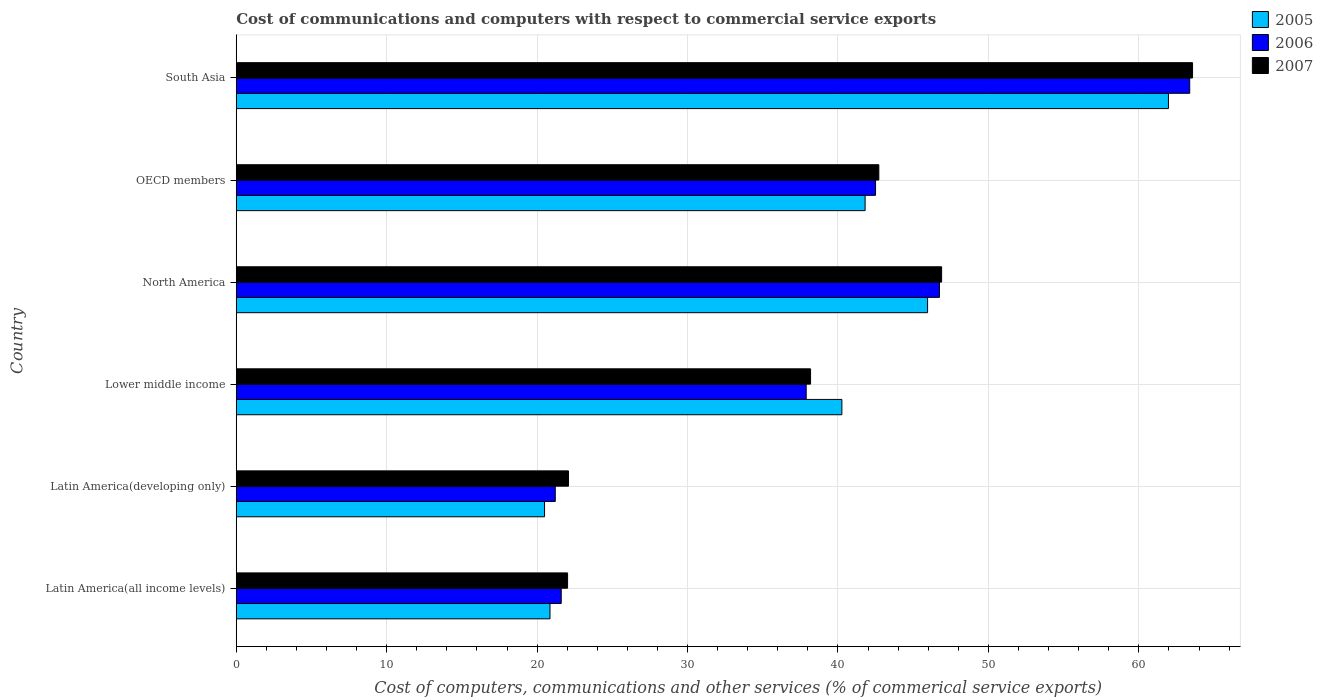How many groups of bars are there?
Offer a very short reply. 6. Are the number of bars on each tick of the Y-axis equal?
Ensure brevity in your answer.  Yes. How many bars are there on the 4th tick from the bottom?
Your answer should be compact. 3. What is the label of the 4th group of bars from the top?
Keep it short and to the point. Lower middle income. What is the cost of communications and computers in 2005 in OECD members?
Your answer should be very brief. 41.8. Across all countries, what is the maximum cost of communications and computers in 2005?
Make the answer very short. 61.97. Across all countries, what is the minimum cost of communications and computers in 2007?
Give a very brief answer. 22.02. In which country was the cost of communications and computers in 2006 maximum?
Keep it short and to the point. South Asia. In which country was the cost of communications and computers in 2006 minimum?
Your answer should be compact. Latin America(developing only). What is the total cost of communications and computers in 2007 in the graph?
Your response must be concise. 235.46. What is the difference between the cost of communications and computers in 2007 in Latin America(all income levels) and that in Lower middle income?
Give a very brief answer. -16.15. What is the difference between the cost of communications and computers in 2007 in Lower middle income and the cost of communications and computers in 2005 in North America?
Keep it short and to the point. -7.78. What is the average cost of communications and computers in 2006 per country?
Your response must be concise. 38.89. What is the difference between the cost of communications and computers in 2007 and cost of communications and computers in 2006 in North America?
Provide a succinct answer. 0.14. In how many countries, is the cost of communications and computers in 2007 greater than 56 %?
Give a very brief answer. 1. What is the ratio of the cost of communications and computers in 2007 in Latin America(developing only) to that in North America?
Give a very brief answer. 0.47. Is the difference between the cost of communications and computers in 2007 in Latin America(developing only) and North America greater than the difference between the cost of communications and computers in 2006 in Latin America(developing only) and North America?
Keep it short and to the point. Yes. What is the difference between the highest and the second highest cost of communications and computers in 2006?
Your response must be concise. 16.63. What is the difference between the highest and the lowest cost of communications and computers in 2007?
Your response must be concise. 41.55. In how many countries, is the cost of communications and computers in 2007 greater than the average cost of communications and computers in 2007 taken over all countries?
Provide a short and direct response. 3. Is the sum of the cost of communications and computers in 2006 in Latin America(all income levels) and North America greater than the maximum cost of communications and computers in 2005 across all countries?
Offer a very short reply. Yes. What does the 2nd bar from the bottom in Latin America(developing only) represents?
Keep it short and to the point. 2006. How many bars are there?
Your answer should be compact. 18. Are all the bars in the graph horizontal?
Provide a short and direct response. Yes. What is the difference between two consecutive major ticks on the X-axis?
Offer a very short reply. 10. Does the graph contain any zero values?
Ensure brevity in your answer.  No. Does the graph contain grids?
Provide a succinct answer. Yes. How many legend labels are there?
Offer a terse response. 3. How are the legend labels stacked?
Ensure brevity in your answer.  Vertical. What is the title of the graph?
Ensure brevity in your answer.  Cost of communications and computers with respect to commercial service exports. Does "1980" appear as one of the legend labels in the graph?
Make the answer very short. No. What is the label or title of the X-axis?
Your answer should be compact. Cost of computers, communications and other services (% of commerical service exports). What is the Cost of computers, communications and other services (% of commerical service exports) of 2005 in Latin America(all income levels)?
Your response must be concise. 20.86. What is the Cost of computers, communications and other services (% of commerical service exports) in 2006 in Latin America(all income levels)?
Give a very brief answer. 21.6. What is the Cost of computers, communications and other services (% of commerical service exports) of 2007 in Latin America(all income levels)?
Your answer should be compact. 22.02. What is the Cost of computers, communications and other services (% of commerical service exports) in 2005 in Latin America(developing only)?
Provide a short and direct response. 20.49. What is the Cost of computers, communications and other services (% of commerical service exports) in 2006 in Latin America(developing only)?
Your answer should be very brief. 21.21. What is the Cost of computers, communications and other services (% of commerical service exports) of 2007 in Latin America(developing only)?
Give a very brief answer. 22.09. What is the Cost of computers, communications and other services (% of commerical service exports) of 2005 in Lower middle income?
Your answer should be compact. 40.26. What is the Cost of computers, communications and other services (% of commerical service exports) of 2006 in Lower middle income?
Your response must be concise. 37.89. What is the Cost of computers, communications and other services (% of commerical service exports) in 2007 in Lower middle income?
Make the answer very short. 38.18. What is the Cost of computers, communications and other services (% of commerical service exports) in 2005 in North America?
Offer a very short reply. 45.96. What is the Cost of computers, communications and other services (% of commerical service exports) in 2006 in North America?
Provide a succinct answer. 46.75. What is the Cost of computers, communications and other services (% of commerical service exports) of 2007 in North America?
Your response must be concise. 46.89. What is the Cost of computers, communications and other services (% of commerical service exports) in 2005 in OECD members?
Give a very brief answer. 41.8. What is the Cost of computers, communications and other services (% of commerical service exports) of 2006 in OECD members?
Provide a succinct answer. 42.5. What is the Cost of computers, communications and other services (% of commerical service exports) in 2007 in OECD members?
Offer a terse response. 42.72. What is the Cost of computers, communications and other services (% of commerical service exports) in 2005 in South Asia?
Give a very brief answer. 61.97. What is the Cost of computers, communications and other services (% of commerical service exports) of 2006 in South Asia?
Your response must be concise. 63.38. What is the Cost of computers, communications and other services (% of commerical service exports) in 2007 in South Asia?
Your response must be concise. 63.57. Across all countries, what is the maximum Cost of computers, communications and other services (% of commerical service exports) in 2005?
Your answer should be very brief. 61.97. Across all countries, what is the maximum Cost of computers, communications and other services (% of commerical service exports) in 2006?
Ensure brevity in your answer.  63.38. Across all countries, what is the maximum Cost of computers, communications and other services (% of commerical service exports) in 2007?
Provide a short and direct response. 63.57. Across all countries, what is the minimum Cost of computers, communications and other services (% of commerical service exports) of 2005?
Give a very brief answer. 20.49. Across all countries, what is the minimum Cost of computers, communications and other services (% of commerical service exports) in 2006?
Provide a succinct answer. 21.21. Across all countries, what is the minimum Cost of computers, communications and other services (% of commerical service exports) in 2007?
Offer a very short reply. 22.02. What is the total Cost of computers, communications and other services (% of commerical service exports) of 2005 in the graph?
Your answer should be compact. 231.34. What is the total Cost of computers, communications and other services (% of commerical service exports) in 2006 in the graph?
Provide a succinct answer. 233.32. What is the total Cost of computers, communications and other services (% of commerical service exports) in 2007 in the graph?
Offer a terse response. 235.46. What is the difference between the Cost of computers, communications and other services (% of commerical service exports) of 2005 in Latin America(all income levels) and that in Latin America(developing only)?
Give a very brief answer. 0.36. What is the difference between the Cost of computers, communications and other services (% of commerical service exports) in 2006 in Latin America(all income levels) and that in Latin America(developing only)?
Your answer should be very brief. 0.4. What is the difference between the Cost of computers, communications and other services (% of commerical service exports) of 2007 in Latin America(all income levels) and that in Latin America(developing only)?
Offer a terse response. -0.06. What is the difference between the Cost of computers, communications and other services (% of commerical service exports) in 2005 in Latin America(all income levels) and that in Lower middle income?
Make the answer very short. -19.4. What is the difference between the Cost of computers, communications and other services (% of commerical service exports) of 2006 in Latin America(all income levels) and that in Lower middle income?
Provide a succinct answer. -16.28. What is the difference between the Cost of computers, communications and other services (% of commerical service exports) in 2007 in Latin America(all income levels) and that in Lower middle income?
Provide a succinct answer. -16.15. What is the difference between the Cost of computers, communications and other services (% of commerical service exports) in 2005 in Latin America(all income levels) and that in North America?
Provide a short and direct response. -25.1. What is the difference between the Cost of computers, communications and other services (% of commerical service exports) in 2006 in Latin America(all income levels) and that in North America?
Provide a short and direct response. -25.14. What is the difference between the Cost of computers, communications and other services (% of commerical service exports) of 2007 in Latin America(all income levels) and that in North America?
Offer a terse response. -24.87. What is the difference between the Cost of computers, communications and other services (% of commerical service exports) of 2005 in Latin America(all income levels) and that in OECD members?
Your response must be concise. -20.95. What is the difference between the Cost of computers, communications and other services (% of commerical service exports) in 2006 in Latin America(all income levels) and that in OECD members?
Keep it short and to the point. -20.89. What is the difference between the Cost of computers, communications and other services (% of commerical service exports) in 2007 in Latin America(all income levels) and that in OECD members?
Provide a succinct answer. -20.69. What is the difference between the Cost of computers, communications and other services (% of commerical service exports) in 2005 in Latin America(all income levels) and that in South Asia?
Offer a very short reply. -41.11. What is the difference between the Cost of computers, communications and other services (% of commerical service exports) of 2006 in Latin America(all income levels) and that in South Asia?
Offer a very short reply. -41.78. What is the difference between the Cost of computers, communications and other services (% of commerical service exports) in 2007 in Latin America(all income levels) and that in South Asia?
Your response must be concise. -41.55. What is the difference between the Cost of computers, communications and other services (% of commerical service exports) of 2005 in Latin America(developing only) and that in Lower middle income?
Provide a short and direct response. -19.76. What is the difference between the Cost of computers, communications and other services (% of commerical service exports) in 2006 in Latin America(developing only) and that in Lower middle income?
Offer a very short reply. -16.68. What is the difference between the Cost of computers, communications and other services (% of commerical service exports) of 2007 in Latin America(developing only) and that in Lower middle income?
Offer a very short reply. -16.09. What is the difference between the Cost of computers, communications and other services (% of commerical service exports) of 2005 in Latin America(developing only) and that in North America?
Your answer should be very brief. -25.46. What is the difference between the Cost of computers, communications and other services (% of commerical service exports) in 2006 in Latin America(developing only) and that in North America?
Provide a short and direct response. -25.54. What is the difference between the Cost of computers, communications and other services (% of commerical service exports) in 2007 in Latin America(developing only) and that in North America?
Keep it short and to the point. -24.8. What is the difference between the Cost of computers, communications and other services (% of commerical service exports) of 2005 in Latin America(developing only) and that in OECD members?
Offer a terse response. -21.31. What is the difference between the Cost of computers, communications and other services (% of commerical service exports) of 2006 in Latin America(developing only) and that in OECD members?
Provide a short and direct response. -21.29. What is the difference between the Cost of computers, communications and other services (% of commerical service exports) in 2007 in Latin America(developing only) and that in OECD members?
Your response must be concise. -20.63. What is the difference between the Cost of computers, communications and other services (% of commerical service exports) of 2005 in Latin America(developing only) and that in South Asia?
Your answer should be very brief. -41.47. What is the difference between the Cost of computers, communications and other services (% of commerical service exports) in 2006 in Latin America(developing only) and that in South Asia?
Your answer should be very brief. -42.17. What is the difference between the Cost of computers, communications and other services (% of commerical service exports) of 2007 in Latin America(developing only) and that in South Asia?
Give a very brief answer. -41.48. What is the difference between the Cost of computers, communications and other services (% of commerical service exports) in 2005 in Lower middle income and that in North America?
Keep it short and to the point. -5.7. What is the difference between the Cost of computers, communications and other services (% of commerical service exports) in 2006 in Lower middle income and that in North America?
Make the answer very short. -8.86. What is the difference between the Cost of computers, communications and other services (% of commerical service exports) in 2007 in Lower middle income and that in North America?
Your response must be concise. -8.71. What is the difference between the Cost of computers, communications and other services (% of commerical service exports) of 2005 in Lower middle income and that in OECD members?
Give a very brief answer. -1.54. What is the difference between the Cost of computers, communications and other services (% of commerical service exports) in 2006 in Lower middle income and that in OECD members?
Your response must be concise. -4.61. What is the difference between the Cost of computers, communications and other services (% of commerical service exports) of 2007 in Lower middle income and that in OECD members?
Provide a succinct answer. -4.54. What is the difference between the Cost of computers, communications and other services (% of commerical service exports) in 2005 in Lower middle income and that in South Asia?
Give a very brief answer. -21.71. What is the difference between the Cost of computers, communications and other services (% of commerical service exports) in 2006 in Lower middle income and that in South Asia?
Keep it short and to the point. -25.5. What is the difference between the Cost of computers, communications and other services (% of commerical service exports) in 2007 in Lower middle income and that in South Asia?
Give a very brief answer. -25.39. What is the difference between the Cost of computers, communications and other services (% of commerical service exports) in 2005 in North America and that in OECD members?
Your response must be concise. 4.15. What is the difference between the Cost of computers, communications and other services (% of commerical service exports) in 2006 in North America and that in OECD members?
Keep it short and to the point. 4.25. What is the difference between the Cost of computers, communications and other services (% of commerical service exports) in 2007 in North America and that in OECD members?
Your response must be concise. 4.17. What is the difference between the Cost of computers, communications and other services (% of commerical service exports) in 2005 in North America and that in South Asia?
Keep it short and to the point. -16.01. What is the difference between the Cost of computers, communications and other services (% of commerical service exports) of 2006 in North America and that in South Asia?
Give a very brief answer. -16.63. What is the difference between the Cost of computers, communications and other services (% of commerical service exports) in 2007 in North America and that in South Asia?
Ensure brevity in your answer.  -16.68. What is the difference between the Cost of computers, communications and other services (% of commerical service exports) of 2005 in OECD members and that in South Asia?
Keep it short and to the point. -20.16. What is the difference between the Cost of computers, communications and other services (% of commerical service exports) in 2006 in OECD members and that in South Asia?
Give a very brief answer. -20.88. What is the difference between the Cost of computers, communications and other services (% of commerical service exports) in 2007 in OECD members and that in South Asia?
Offer a terse response. -20.85. What is the difference between the Cost of computers, communications and other services (% of commerical service exports) in 2005 in Latin America(all income levels) and the Cost of computers, communications and other services (% of commerical service exports) in 2006 in Latin America(developing only)?
Offer a very short reply. -0.35. What is the difference between the Cost of computers, communications and other services (% of commerical service exports) of 2005 in Latin America(all income levels) and the Cost of computers, communications and other services (% of commerical service exports) of 2007 in Latin America(developing only)?
Offer a very short reply. -1.23. What is the difference between the Cost of computers, communications and other services (% of commerical service exports) of 2006 in Latin America(all income levels) and the Cost of computers, communications and other services (% of commerical service exports) of 2007 in Latin America(developing only)?
Provide a short and direct response. -0.48. What is the difference between the Cost of computers, communications and other services (% of commerical service exports) in 2005 in Latin America(all income levels) and the Cost of computers, communications and other services (% of commerical service exports) in 2006 in Lower middle income?
Your answer should be compact. -17.03. What is the difference between the Cost of computers, communications and other services (% of commerical service exports) of 2005 in Latin America(all income levels) and the Cost of computers, communications and other services (% of commerical service exports) of 2007 in Lower middle income?
Offer a very short reply. -17.32. What is the difference between the Cost of computers, communications and other services (% of commerical service exports) in 2006 in Latin America(all income levels) and the Cost of computers, communications and other services (% of commerical service exports) in 2007 in Lower middle income?
Your answer should be very brief. -16.57. What is the difference between the Cost of computers, communications and other services (% of commerical service exports) in 2005 in Latin America(all income levels) and the Cost of computers, communications and other services (% of commerical service exports) in 2006 in North America?
Keep it short and to the point. -25.89. What is the difference between the Cost of computers, communications and other services (% of commerical service exports) in 2005 in Latin America(all income levels) and the Cost of computers, communications and other services (% of commerical service exports) in 2007 in North America?
Your response must be concise. -26.03. What is the difference between the Cost of computers, communications and other services (% of commerical service exports) of 2006 in Latin America(all income levels) and the Cost of computers, communications and other services (% of commerical service exports) of 2007 in North America?
Your answer should be compact. -25.29. What is the difference between the Cost of computers, communications and other services (% of commerical service exports) of 2005 in Latin America(all income levels) and the Cost of computers, communications and other services (% of commerical service exports) of 2006 in OECD members?
Your response must be concise. -21.64. What is the difference between the Cost of computers, communications and other services (% of commerical service exports) of 2005 in Latin America(all income levels) and the Cost of computers, communications and other services (% of commerical service exports) of 2007 in OECD members?
Make the answer very short. -21.86. What is the difference between the Cost of computers, communications and other services (% of commerical service exports) of 2006 in Latin America(all income levels) and the Cost of computers, communications and other services (% of commerical service exports) of 2007 in OECD members?
Offer a very short reply. -21.11. What is the difference between the Cost of computers, communications and other services (% of commerical service exports) in 2005 in Latin America(all income levels) and the Cost of computers, communications and other services (% of commerical service exports) in 2006 in South Asia?
Provide a succinct answer. -42.52. What is the difference between the Cost of computers, communications and other services (% of commerical service exports) of 2005 in Latin America(all income levels) and the Cost of computers, communications and other services (% of commerical service exports) of 2007 in South Asia?
Offer a terse response. -42.71. What is the difference between the Cost of computers, communications and other services (% of commerical service exports) of 2006 in Latin America(all income levels) and the Cost of computers, communications and other services (% of commerical service exports) of 2007 in South Asia?
Make the answer very short. -41.97. What is the difference between the Cost of computers, communications and other services (% of commerical service exports) in 2005 in Latin America(developing only) and the Cost of computers, communications and other services (% of commerical service exports) in 2006 in Lower middle income?
Your answer should be compact. -17.39. What is the difference between the Cost of computers, communications and other services (% of commerical service exports) in 2005 in Latin America(developing only) and the Cost of computers, communications and other services (% of commerical service exports) in 2007 in Lower middle income?
Your response must be concise. -17.68. What is the difference between the Cost of computers, communications and other services (% of commerical service exports) of 2006 in Latin America(developing only) and the Cost of computers, communications and other services (% of commerical service exports) of 2007 in Lower middle income?
Your answer should be compact. -16.97. What is the difference between the Cost of computers, communications and other services (% of commerical service exports) of 2005 in Latin America(developing only) and the Cost of computers, communications and other services (% of commerical service exports) of 2006 in North America?
Give a very brief answer. -26.25. What is the difference between the Cost of computers, communications and other services (% of commerical service exports) in 2005 in Latin America(developing only) and the Cost of computers, communications and other services (% of commerical service exports) in 2007 in North America?
Your response must be concise. -26.4. What is the difference between the Cost of computers, communications and other services (% of commerical service exports) in 2006 in Latin America(developing only) and the Cost of computers, communications and other services (% of commerical service exports) in 2007 in North America?
Keep it short and to the point. -25.68. What is the difference between the Cost of computers, communications and other services (% of commerical service exports) of 2005 in Latin America(developing only) and the Cost of computers, communications and other services (% of commerical service exports) of 2006 in OECD members?
Your answer should be very brief. -22. What is the difference between the Cost of computers, communications and other services (% of commerical service exports) in 2005 in Latin America(developing only) and the Cost of computers, communications and other services (% of commerical service exports) in 2007 in OECD members?
Your response must be concise. -22.22. What is the difference between the Cost of computers, communications and other services (% of commerical service exports) in 2006 in Latin America(developing only) and the Cost of computers, communications and other services (% of commerical service exports) in 2007 in OECD members?
Offer a very short reply. -21.51. What is the difference between the Cost of computers, communications and other services (% of commerical service exports) of 2005 in Latin America(developing only) and the Cost of computers, communications and other services (% of commerical service exports) of 2006 in South Asia?
Your answer should be very brief. -42.89. What is the difference between the Cost of computers, communications and other services (% of commerical service exports) of 2005 in Latin America(developing only) and the Cost of computers, communications and other services (% of commerical service exports) of 2007 in South Asia?
Offer a very short reply. -43.08. What is the difference between the Cost of computers, communications and other services (% of commerical service exports) in 2006 in Latin America(developing only) and the Cost of computers, communications and other services (% of commerical service exports) in 2007 in South Asia?
Ensure brevity in your answer.  -42.36. What is the difference between the Cost of computers, communications and other services (% of commerical service exports) of 2005 in Lower middle income and the Cost of computers, communications and other services (% of commerical service exports) of 2006 in North America?
Provide a short and direct response. -6.49. What is the difference between the Cost of computers, communications and other services (% of commerical service exports) in 2005 in Lower middle income and the Cost of computers, communications and other services (% of commerical service exports) in 2007 in North America?
Your response must be concise. -6.63. What is the difference between the Cost of computers, communications and other services (% of commerical service exports) of 2006 in Lower middle income and the Cost of computers, communications and other services (% of commerical service exports) of 2007 in North America?
Keep it short and to the point. -9. What is the difference between the Cost of computers, communications and other services (% of commerical service exports) in 2005 in Lower middle income and the Cost of computers, communications and other services (% of commerical service exports) in 2006 in OECD members?
Keep it short and to the point. -2.24. What is the difference between the Cost of computers, communications and other services (% of commerical service exports) in 2005 in Lower middle income and the Cost of computers, communications and other services (% of commerical service exports) in 2007 in OECD members?
Provide a succinct answer. -2.46. What is the difference between the Cost of computers, communications and other services (% of commerical service exports) of 2006 in Lower middle income and the Cost of computers, communications and other services (% of commerical service exports) of 2007 in OECD members?
Offer a very short reply. -4.83. What is the difference between the Cost of computers, communications and other services (% of commerical service exports) of 2005 in Lower middle income and the Cost of computers, communications and other services (% of commerical service exports) of 2006 in South Asia?
Ensure brevity in your answer.  -23.12. What is the difference between the Cost of computers, communications and other services (% of commerical service exports) of 2005 in Lower middle income and the Cost of computers, communications and other services (% of commerical service exports) of 2007 in South Asia?
Keep it short and to the point. -23.31. What is the difference between the Cost of computers, communications and other services (% of commerical service exports) of 2006 in Lower middle income and the Cost of computers, communications and other services (% of commerical service exports) of 2007 in South Asia?
Ensure brevity in your answer.  -25.68. What is the difference between the Cost of computers, communications and other services (% of commerical service exports) in 2005 in North America and the Cost of computers, communications and other services (% of commerical service exports) in 2006 in OECD members?
Provide a succinct answer. 3.46. What is the difference between the Cost of computers, communications and other services (% of commerical service exports) in 2005 in North America and the Cost of computers, communications and other services (% of commerical service exports) in 2007 in OECD members?
Give a very brief answer. 3.24. What is the difference between the Cost of computers, communications and other services (% of commerical service exports) of 2006 in North America and the Cost of computers, communications and other services (% of commerical service exports) of 2007 in OECD members?
Give a very brief answer. 4.03. What is the difference between the Cost of computers, communications and other services (% of commerical service exports) of 2005 in North America and the Cost of computers, communications and other services (% of commerical service exports) of 2006 in South Asia?
Keep it short and to the point. -17.43. What is the difference between the Cost of computers, communications and other services (% of commerical service exports) of 2005 in North America and the Cost of computers, communications and other services (% of commerical service exports) of 2007 in South Asia?
Offer a terse response. -17.61. What is the difference between the Cost of computers, communications and other services (% of commerical service exports) of 2006 in North America and the Cost of computers, communications and other services (% of commerical service exports) of 2007 in South Asia?
Provide a short and direct response. -16.82. What is the difference between the Cost of computers, communications and other services (% of commerical service exports) in 2005 in OECD members and the Cost of computers, communications and other services (% of commerical service exports) in 2006 in South Asia?
Give a very brief answer. -21.58. What is the difference between the Cost of computers, communications and other services (% of commerical service exports) of 2005 in OECD members and the Cost of computers, communications and other services (% of commerical service exports) of 2007 in South Asia?
Give a very brief answer. -21.77. What is the difference between the Cost of computers, communications and other services (% of commerical service exports) in 2006 in OECD members and the Cost of computers, communications and other services (% of commerical service exports) in 2007 in South Asia?
Provide a short and direct response. -21.07. What is the average Cost of computers, communications and other services (% of commerical service exports) in 2005 per country?
Make the answer very short. 38.56. What is the average Cost of computers, communications and other services (% of commerical service exports) in 2006 per country?
Your response must be concise. 38.89. What is the average Cost of computers, communications and other services (% of commerical service exports) of 2007 per country?
Make the answer very short. 39.24. What is the difference between the Cost of computers, communications and other services (% of commerical service exports) in 2005 and Cost of computers, communications and other services (% of commerical service exports) in 2006 in Latin America(all income levels)?
Your answer should be compact. -0.75. What is the difference between the Cost of computers, communications and other services (% of commerical service exports) in 2005 and Cost of computers, communications and other services (% of commerical service exports) in 2007 in Latin America(all income levels)?
Provide a short and direct response. -1.17. What is the difference between the Cost of computers, communications and other services (% of commerical service exports) in 2006 and Cost of computers, communications and other services (% of commerical service exports) in 2007 in Latin America(all income levels)?
Make the answer very short. -0.42. What is the difference between the Cost of computers, communications and other services (% of commerical service exports) in 2005 and Cost of computers, communications and other services (% of commerical service exports) in 2006 in Latin America(developing only)?
Keep it short and to the point. -0.71. What is the difference between the Cost of computers, communications and other services (% of commerical service exports) in 2005 and Cost of computers, communications and other services (% of commerical service exports) in 2007 in Latin America(developing only)?
Your response must be concise. -1.59. What is the difference between the Cost of computers, communications and other services (% of commerical service exports) in 2006 and Cost of computers, communications and other services (% of commerical service exports) in 2007 in Latin America(developing only)?
Make the answer very short. -0.88. What is the difference between the Cost of computers, communications and other services (% of commerical service exports) in 2005 and Cost of computers, communications and other services (% of commerical service exports) in 2006 in Lower middle income?
Provide a short and direct response. 2.37. What is the difference between the Cost of computers, communications and other services (% of commerical service exports) of 2005 and Cost of computers, communications and other services (% of commerical service exports) of 2007 in Lower middle income?
Your response must be concise. 2.08. What is the difference between the Cost of computers, communications and other services (% of commerical service exports) in 2006 and Cost of computers, communications and other services (% of commerical service exports) in 2007 in Lower middle income?
Make the answer very short. -0.29. What is the difference between the Cost of computers, communications and other services (% of commerical service exports) of 2005 and Cost of computers, communications and other services (% of commerical service exports) of 2006 in North America?
Your answer should be very brief. -0.79. What is the difference between the Cost of computers, communications and other services (% of commerical service exports) in 2005 and Cost of computers, communications and other services (% of commerical service exports) in 2007 in North America?
Make the answer very short. -0.93. What is the difference between the Cost of computers, communications and other services (% of commerical service exports) of 2006 and Cost of computers, communications and other services (% of commerical service exports) of 2007 in North America?
Keep it short and to the point. -0.14. What is the difference between the Cost of computers, communications and other services (% of commerical service exports) in 2005 and Cost of computers, communications and other services (% of commerical service exports) in 2006 in OECD members?
Your answer should be very brief. -0.69. What is the difference between the Cost of computers, communications and other services (% of commerical service exports) in 2005 and Cost of computers, communications and other services (% of commerical service exports) in 2007 in OECD members?
Offer a terse response. -0.91. What is the difference between the Cost of computers, communications and other services (% of commerical service exports) of 2006 and Cost of computers, communications and other services (% of commerical service exports) of 2007 in OECD members?
Your answer should be very brief. -0.22. What is the difference between the Cost of computers, communications and other services (% of commerical service exports) in 2005 and Cost of computers, communications and other services (% of commerical service exports) in 2006 in South Asia?
Your response must be concise. -1.41. What is the difference between the Cost of computers, communications and other services (% of commerical service exports) in 2005 and Cost of computers, communications and other services (% of commerical service exports) in 2007 in South Asia?
Your response must be concise. -1.6. What is the difference between the Cost of computers, communications and other services (% of commerical service exports) in 2006 and Cost of computers, communications and other services (% of commerical service exports) in 2007 in South Asia?
Provide a succinct answer. -0.19. What is the ratio of the Cost of computers, communications and other services (% of commerical service exports) in 2005 in Latin America(all income levels) to that in Latin America(developing only)?
Offer a very short reply. 1.02. What is the ratio of the Cost of computers, communications and other services (% of commerical service exports) of 2006 in Latin America(all income levels) to that in Latin America(developing only)?
Offer a very short reply. 1.02. What is the ratio of the Cost of computers, communications and other services (% of commerical service exports) in 2005 in Latin America(all income levels) to that in Lower middle income?
Give a very brief answer. 0.52. What is the ratio of the Cost of computers, communications and other services (% of commerical service exports) of 2006 in Latin America(all income levels) to that in Lower middle income?
Your response must be concise. 0.57. What is the ratio of the Cost of computers, communications and other services (% of commerical service exports) of 2007 in Latin America(all income levels) to that in Lower middle income?
Your response must be concise. 0.58. What is the ratio of the Cost of computers, communications and other services (% of commerical service exports) of 2005 in Latin America(all income levels) to that in North America?
Give a very brief answer. 0.45. What is the ratio of the Cost of computers, communications and other services (% of commerical service exports) in 2006 in Latin America(all income levels) to that in North America?
Make the answer very short. 0.46. What is the ratio of the Cost of computers, communications and other services (% of commerical service exports) in 2007 in Latin America(all income levels) to that in North America?
Give a very brief answer. 0.47. What is the ratio of the Cost of computers, communications and other services (% of commerical service exports) of 2005 in Latin America(all income levels) to that in OECD members?
Provide a succinct answer. 0.5. What is the ratio of the Cost of computers, communications and other services (% of commerical service exports) in 2006 in Latin America(all income levels) to that in OECD members?
Ensure brevity in your answer.  0.51. What is the ratio of the Cost of computers, communications and other services (% of commerical service exports) in 2007 in Latin America(all income levels) to that in OECD members?
Your answer should be compact. 0.52. What is the ratio of the Cost of computers, communications and other services (% of commerical service exports) of 2005 in Latin America(all income levels) to that in South Asia?
Offer a very short reply. 0.34. What is the ratio of the Cost of computers, communications and other services (% of commerical service exports) in 2006 in Latin America(all income levels) to that in South Asia?
Keep it short and to the point. 0.34. What is the ratio of the Cost of computers, communications and other services (% of commerical service exports) in 2007 in Latin America(all income levels) to that in South Asia?
Ensure brevity in your answer.  0.35. What is the ratio of the Cost of computers, communications and other services (% of commerical service exports) of 2005 in Latin America(developing only) to that in Lower middle income?
Your answer should be compact. 0.51. What is the ratio of the Cost of computers, communications and other services (% of commerical service exports) in 2006 in Latin America(developing only) to that in Lower middle income?
Provide a succinct answer. 0.56. What is the ratio of the Cost of computers, communications and other services (% of commerical service exports) in 2007 in Latin America(developing only) to that in Lower middle income?
Offer a terse response. 0.58. What is the ratio of the Cost of computers, communications and other services (% of commerical service exports) in 2005 in Latin America(developing only) to that in North America?
Ensure brevity in your answer.  0.45. What is the ratio of the Cost of computers, communications and other services (% of commerical service exports) in 2006 in Latin America(developing only) to that in North America?
Make the answer very short. 0.45. What is the ratio of the Cost of computers, communications and other services (% of commerical service exports) of 2007 in Latin America(developing only) to that in North America?
Give a very brief answer. 0.47. What is the ratio of the Cost of computers, communications and other services (% of commerical service exports) of 2005 in Latin America(developing only) to that in OECD members?
Your response must be concise. 0.49. What is the ratio of the Cost of computers, communications and other services (% of commerical service exports) in 2006 in Latin America(developing only) to that in OECD members?
Offer a terse response. 0.5. What is the ratio of the Cost of computers, communications and other services (% of commerical service exports) in 2007 in Latin America(developing only) to that in OECD members?
Your answer should be very brief. 0.52. What is the ratio of the Cost of computers, communications and other services (% of commerical service exports) of 2005 in Latin America(developing only) to that in South Asia?
Your answer should be very brief. 0.33. What is the ratio of the Cost of computers, communications and other services (% of commerical service exports) of 2006 in Latin America(developing only) to that in South Asia?
Offer a very short reply. 0.33. What is the ratio of the Cost of computers, communications and other services (% of commerical service exports) in 2007 in Latin America(developing only) to that in South Asia?
Offer a terse response. 0.35. What is the ratio of the Cost of computers, communications and other services (% of commerical service exports) in 2005 in Lower middle income to that in North America?
Make the answer very short. 0.88. What is the ratio of the Cost of computers, communications and other services (% of commerical service exports) of 2006 in Lower middle income to that in North America?
Offer a very short reply. 0.81. What is the ratio of the Cost of computers, communications and other services (% of commerical service exports) in 2007 in Lower middle income to that in North America?
Ensure brevity in your answer.  0.81. What is the ratio of the Cost of computers, communications and other services (% of commerical service exports) in 2005 in Lower middle income to that in OECD members?
Offer a terse response. 0.96. What is the ratio of the Cost of computers, communications and other services (% of commerical service exports) in 2006 in Lower middle income to that in OECD members?
Offer a terse response. 0.89. What is the ratio of the Cost of computers, communications and other services (% of commerical service exports) in 2007 in Lower middle income to that in OECD members?
Your answer should be very brief. 0.89. What is the ratio of the Cost of computers, communications and other services (% of commerical service exports) of 2005 in Lower middle income to that in South Asia?
Provide a short and direct response. 0.65. What is the ratio of the Cost of computers, communications and other services (% of commerical service exports) in 2006 in Lower middle income to that in South Asia?
Provide a succinct answer. 0.6. What is the ratio of the Cost of computers, communications and other services (% of commerical service exports) in 2007 in Lower middle income to that in South Asia?
Provide a succinct answer. 0.6. What is the ratio of the Cost of computers, communications and other services (% of commerical service exports) of 2005 in North America to that in OECD members?
Provide a succinct answer. 1.1. What is the ratio of the Cost of computers, communications and other services (% of commerical service exports) of 2007 in North America to that in OECD members?
Give a very brief answer. 1.1. What is the ratio of the Cost of computers, communications and other services (% of commerical service exports) of 2005 in North America to that in South Asia?
Your answer should be very brief. 0.74. What is the ratio of the Cost of computers, communications and other services (% of commerical service exports) of 2006 in North America to that in South Asia?
Provide a succinct answer. 0.74. What is the ratio of the Cost of computers, communications and other services (% of commerical service exports) in 2007 in North America to that in South Asia?
Offer a terse response. 0.74. What is the ratio of the Cost of computers, communications and other services (% of commerical service exports) in 2005 in OECD members to that in South Asia?
Ensure brevity in your answer.  0.67. What is the ratio of the Cost of computers, communications and other services (% of commerical service exports) of 2006 in OECD members to that in South Asia?
Your answer should be very brief. 0.67. What is the ratio of the Cost of computers, communications and other services (% of commerical service exports) of 2007 in OECD members to that in South Asia?
Your response must be concise. 0.67. What is the difference between the highest and the second highest Cost of computers, communications and other services (% of commerical service exports) of 2005?
Offer a very short reply. 16.01. What is the difference between the highest and the second highest Cost of computers, communications and other services (% of commerical service exports) in 2006?
Offer a terse response. 16.63. What is the difference between the highest and the second highest Cost of computers, communications and other services (% of commerical service exports) in 2007?
Ensure brevity in your answer.  16.68. What is the difference between the highest and the lowest Cost of computers, communications and other services (% of commerical service exports) in 2005?
Provide a short and direct response. 41.47. What is the difference between the highest and the lowest Cost of computers, communications and other services (% of commerical service exports) in 2006?
Offer a very short reply. 42.17. What is the difference between the highest and the lowest Cost of computers, communications and other services (% of commerical service exports) of 2007?
Give a very brief answer. 41.55. 